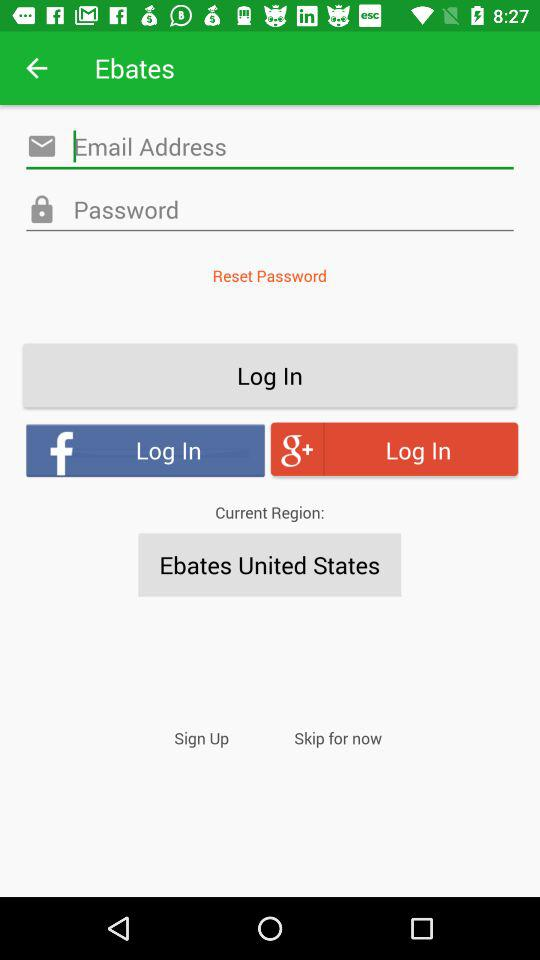What is the current region? The current region is Ebates United States. 